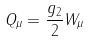<formula> <loc_0><loc_0><loc_500><loc_500>Q _ { \mu } = \frac { g _ { 2 } } { 2 } W _ { \mu }</formula> 